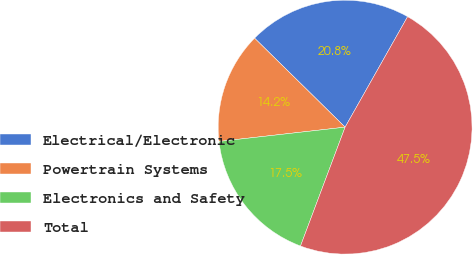Convert chart. <chart><loc_0><loc_0><loc_500><loc_500><pie_chart><fcel>Electrical/Electronic<fcel>Powertrain Systems<fcel>Electronics and Safety<fcel>Total<nl><fcel>20.83%<fcel>14.16%<fcel>17.49%<fcel>47.52%<nl></chart> 